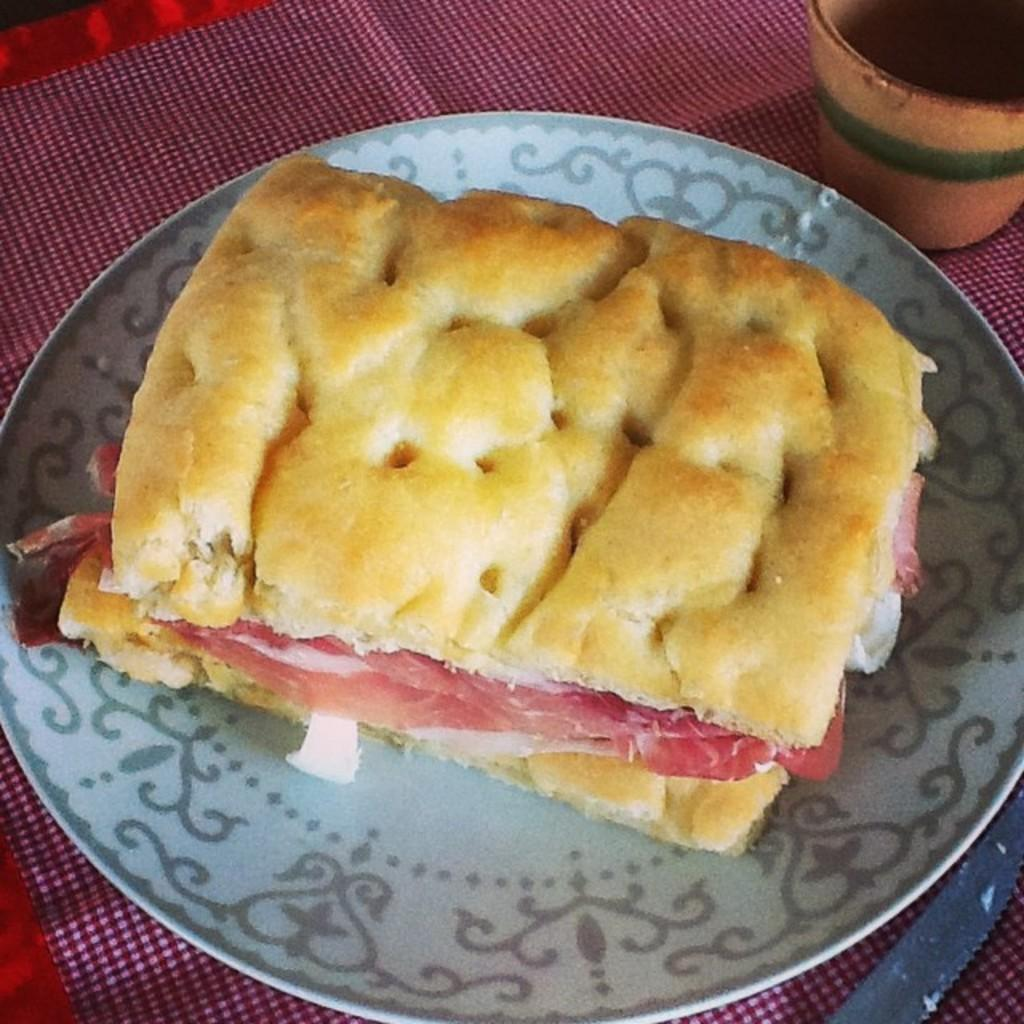What is located in the center of the image? There is a table in the center of the image. What is covering the table? There is a cloth on the table. What objects can be seen on the table? There is a glass, a knife, and a plate on the table. What is on the plate? There is food in the plate. How many people are in the crowd watching the basketball game in the image? There is no crowd or basketball game present in the image; it features a table with various objects on it. 